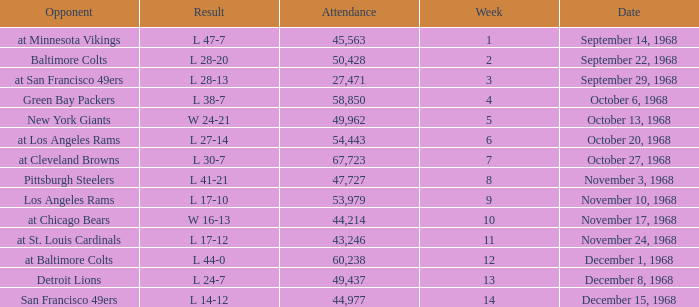Could you help me parse every detail presented in this table? {'header': ['Opponent', 'Result', 'Attendance', 'Week', 'Date'], 'rows': [['at Minnesota Vikings', 'L 47-7', '45,563', '1', 'September 14, 1968'], ['Baltimore Colts', 'L 28-20', '50,428', '2', 'September 22, 1968'], ['at San Francisco 49ers', 'L 28-13', '27,471', '3', 'September 29, 1968'], ['Green Bay Packers', 'L 38-7', '58,850', '4', 'October 6, 1968'], ['New York Giants', 'W 24-21', '49,962', '5', 'October 13, 1968'], ['at Los Angeles Rams', 'L 27-14', '54,443', '6', 'October 20, 1968'], ['at Cleveland Browns', 'L 30-7', '67,723', '7', 'October 27, 1968'], ['Pittsburgh Steelers', 'L 41-21', '47,727', '8', 'November 3, 1968'], ['Los Angeles Rams', 'L 17-10', '53,979', '9', 'November 10, 1968'], ['at Chicago Bears', 'W 16-13', '44,214', '10', 'November 17, 1968'], ['at St. Louis Cardinals', 'L 17-12', '43,246', '11', 'November 24, 1968'], ['at Baltimore Colts', 'L 44-0', '60,238', '12', 'December 1, 1968'], ['Detroit Lions', 'L 24-7', '49,437', '13', 'December 8, 1968'], ['San Francisco 49ers', 'L 14-12', '44,977', '14', 'December 15, 1968']]} Which Attendance has a Date of september 29, 1968, and a Week smaller than 3? None. 